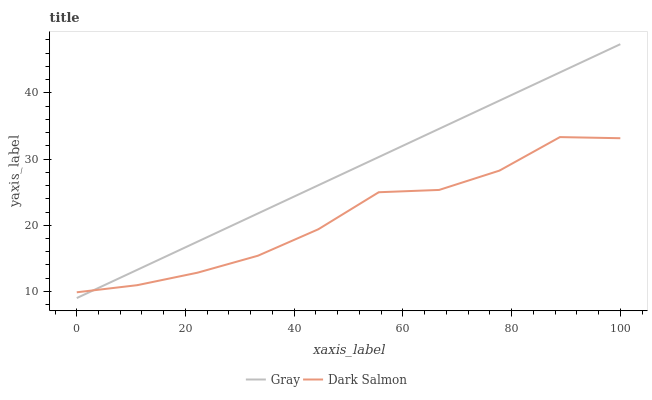Does Dark Salmon have the minimum area under the curve?
Answer yes or no. Yes. Does Gray have the maximum area under the curve?
Answer yes or no. Yes. Does Dark Salmon have the maximum area under the curve?
Answer yes or no. No. Is Gray the smoothest?
Answer yes or no. Yes. Is Dark Salmon the roughest?
Answer yes or no. Yes. Is Dark Salmon the smoothest?
Answer yes or no. No. Does Gray have the lowest value?
Answer yes or no. Yes. Does Dark Salmon have the lowest value?
Answer yes or no. No. Does Gray have the highest value?
Answer yes or no. Yes. Does Dark Salmon have the highest value?
Answer yes or no. No. Does Gray intersect Dark Salmon?
Answer yes or no. Yes. Is Gray less than Dark Salmon?
Answer yes or no. No. Is Gray greater than Dark Salmon?
Answer yes or no. No. 